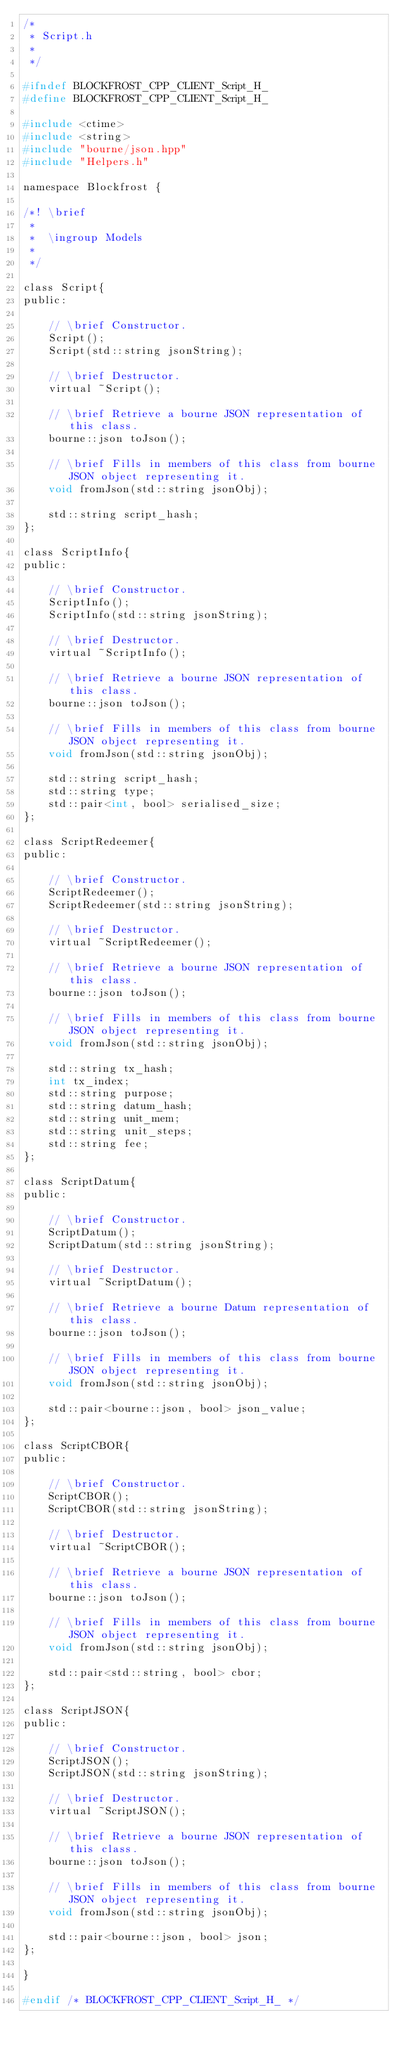Convert code to text. <code><loc_0><loc_0><loc_500><loc_500><_C_>/*
 * Script.h
 *
 */

#ifndef BLOCKFROST_CPP_CLIENT_Script_H_
#define BLOCKFROST_CPP_CLIENT_Script_H_

#include <ctime>
#include <string>
#include "bourne/json.hpp"
#include "Helpers.h"

namespace Blockfrost {

/*! \brief
 *
 *  \ingroup Models
 *
 */

class Script{
public:

    // \brief Constructor.
    Script();
    Script(std::string jsonString);

    // \brief Destructor.
    virtual ~Script();

    // \brief Retrieve a bourne JSON representation of this class.
    bourne::json toJson();

    // \brief Fills in members of this class from bourne JSON object representing it.
    void fromJson(std::string jsonObj);

    std::string script_hash;
};

class ScriptInfo{
public:

    // \brief Constructor.
    ScriptInfo();
    ScriptInfo(std::string jsonString);

    // \brief Destructor.
    virtual ~ScriptInfo();

    // \brief Retrieve a bourne JSON representation of this class.
    bourne::json toJson();

    // \brief Fills in members of this class from bourne JSON object representing it.
    void fromJson(std::string jsonObj);

    std::string script_hash;
    std::string type;
    std::pair<int, bool> serialised_size;
};

class ScriptRedeemer{
public:

    // \brief Constructor.
    ScriptRedeemer();
    ScriptRedeemer(std::string jsonString);

    // \brief Destructor.
    virtual ~ScriptRedeemer();

    // \brief Retrieve a bourne JSON representation of this class.
    bourne::json toJson();

    // \brief Fills in members of this class from bourne JSON object representing it.
    void fromJson(std::string jsonObj);

    std::string tx_hash;
    int tx_index;
    std::string purpose;
    std::string datum_hash;
    std::string unit_mem;
    std::string unit_steps;
    std::string fee;
};

class ScriptDatum{
public:

    // \brief Constructor.
    ScriptDatum();
    ScriptDatum(std::string jsonString);

    // \brief Destructor.
    virtual ~ScriptDatum();

    // \brief Retrieve a bourne Datum representation of this class.
    bourne::json toJson();

    // \brief Fills in members of this class from bourne JSON object representing it.
    void fromJson(std::string jsonObj);

    std::pair<bourne::json, bool> json_value;
};

class ScriptCBOR{
public:

    // \brief Constructor.
    ScriptCBOR();
    ScriptCBOR(std::string jsonString);

    // \brief Destructor.
    virtual ~ScriptCBOR();

    // \brief Retrieve a bourne JSON representation of this class.
    bourne::json toJson();

    // \brief Fills in members of this class from bourne JSON object representing it.
    void fromJson(std::string jsonObj);

    std::pair<std::string, bool> cbor;
};

class ScriptJSON{
public:

    // \brief Constructor.
    ScriptJSON();
    ScriptJSON(std::string jsonString);

    // \brief Destructor.
    virtual ~ScriptJSON();

    // \brief Retrieve a bourne JSON representation of this class.
    bourne::json toJson();

    // \brief Fills in members of this class from bourne JSON object representing it.
    void fromJson(std::string jsonObj);

    std::pair<bourne::json, bool> json;
};

}

#endif /* BLOCKFROST_CPP_CLIENT_Script_H_ */
</code> 